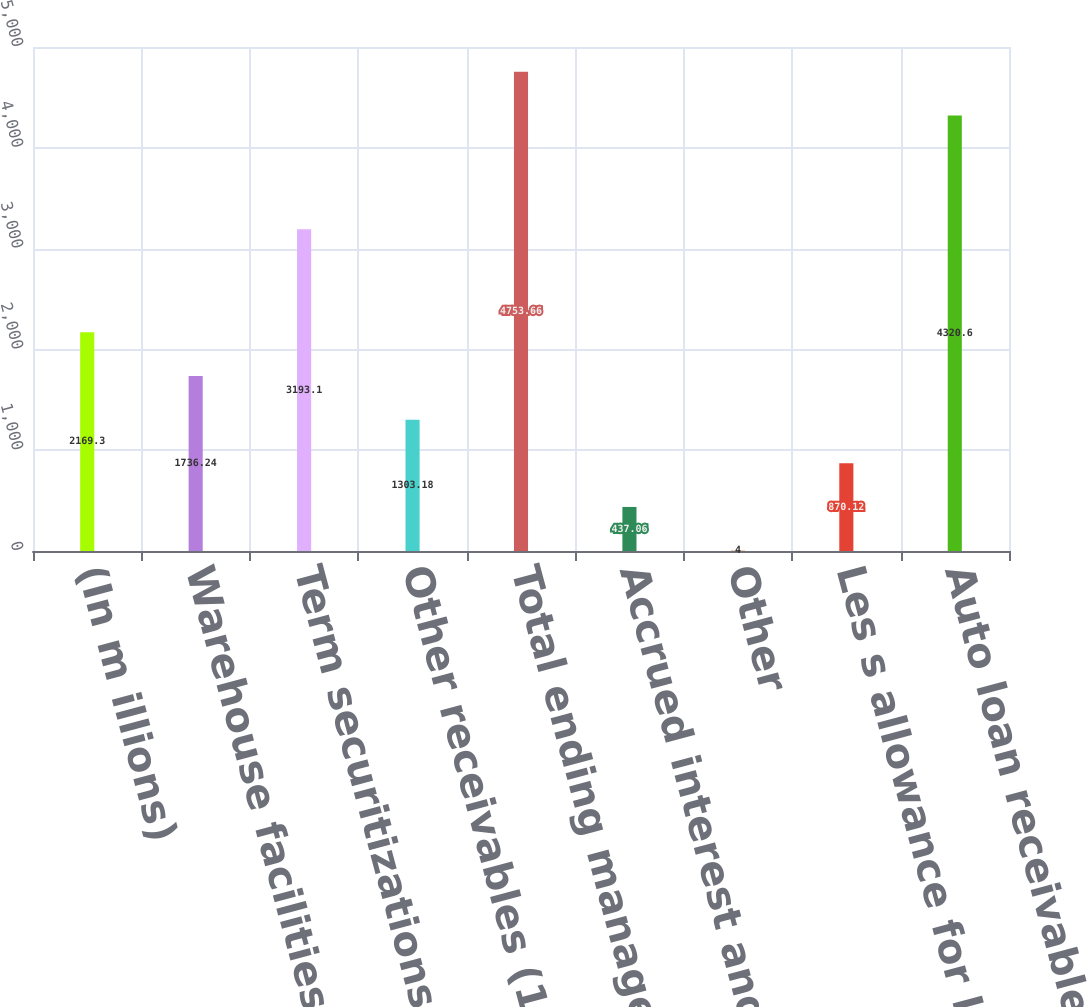Convert chart. <chart><loc_0><loc_0><loc_500><loc_500><bar_chart><fcel>(In m illions)<fcel>Warehouse facilities<fcel>Term securitizations<fcel>Other receivables (1)<fcel>Total ending managed<fcel>Accrued interest and fees<fcel>Other<fcel>Les s allowance for loan los s<fcel>Auto loan receivables net<nl><fcel>2169.3<fcel>1736.24<fcel>3193.1<fcel>1303.18<fcel>4753.66<fcel>437.06<fcel>4<fcel>870.12<fcel>4320.6<nl></chart> 